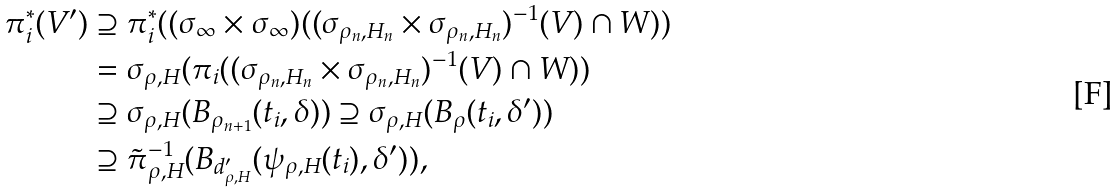<formula> <loc_0><loc_0><loc_500><loc_500>\pi ^ { * } _ { i } ( V ^ { \prime } ) & \supseteq \pi ^ { * } _ { i } ( ( \sigma _ { \infty } \times \sigma _ { \infty } ) ( ( \sigma _ { \rho _ { n } , H _ { n } } \times \sigma _ { \rho _ { n } , H _ { n } } ) ^ { - 1 } ( V ) \cap W ) ) \\ & = \sigma _ { \rho , H } ( \pi _ { i } ( ( \sigma _ { \rho _ { n } , H _ { n } } \times \sigma _ { \rho _ { n } , H _ { n } } ) ^ { - 1 } ( V ) \cap W ) ) \\ & \supseteq \sigma _ { \rho , H } ( B _ { \rho _ { n + 1 } } ( t _ { i } , \delta ) ) \supseteq \sigma _ { \rho , H } ( B _ { \rho } ( t _ { i } , \delta ^ { \prime } ) ) \\ & \supseteq \tilde { \pi } ^ { - 1 } _ { \rho , H } ( B _ { d ^ { \prime } _ { \rho , H } } ( \psi _ { \rho , H } ( t _ { i } ) , \delta ^ { \prime } ) ) ,</formula> 